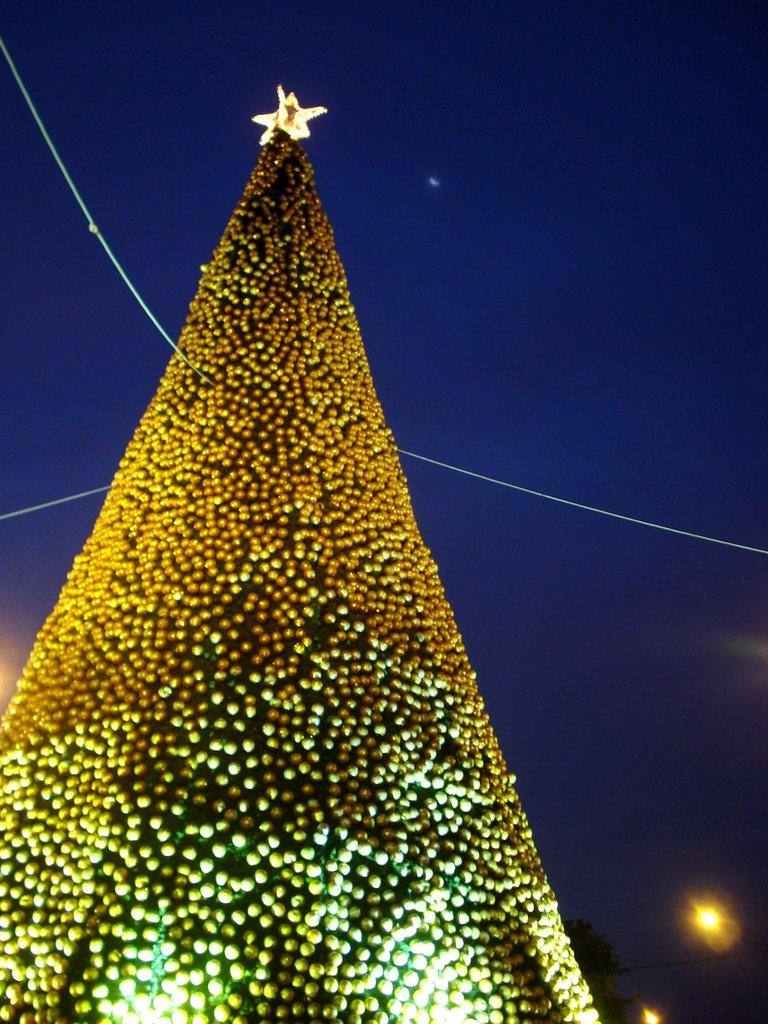What type of tree is in the image? There is a Christmas tree in the image. What is illuminating the tree and the surrounding area? There are lights in the image. What type of foliage is present in the image? There are leaves in the image. What can be seen in the distance in the image? The sky is visible in the background of the image. What impulse did the boys receive to make an offer in the image? There are no boys or offers present in the image; it features a Christmas tree with lights and leaves. 